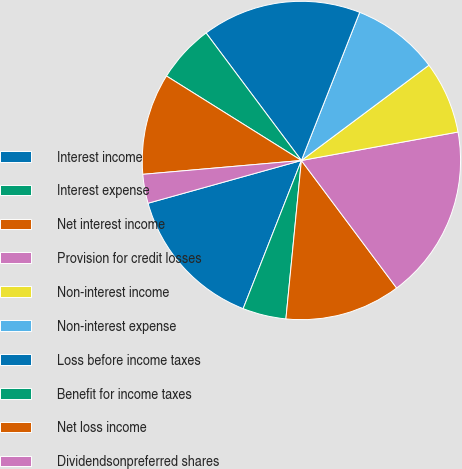<chart> <loc_0><loc_0><loc_500><loc_500><pie_chart><fcel>Interest income<fcel>Interest expense<fcel>Net interest income<fcel>Provision for credit losses<fcel>Non-interest income<fcel>Non-interest expense<fcel>Loss before income taxes<fcel>Benefit for income taxes<fcel>Net loss income<fcel>Dividendsonpreferred shares<nl><fcel>14.71%<fcel>4.41%<fcel>11.76%<fcel>17.65%<fcel>7.35%<fcel>8.82%<fcel>16.18%<fcel>5.88%<fcel>10.29%<fcel>2.94%<nl></chart> 